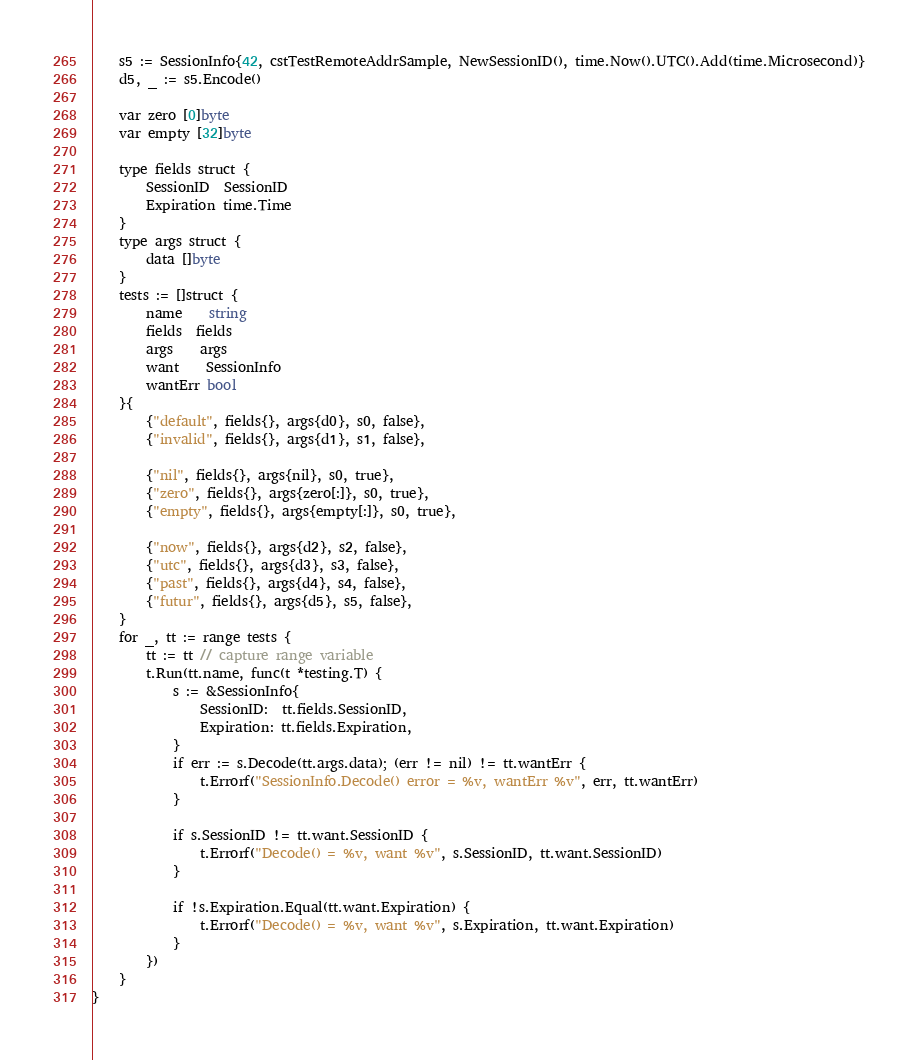<code> <loc_0><loc_0><loc_500><loc_500><_Go_>
	s5 := SessionInfo{42, cstTestRemoteAddrSample, NewSessionID(), time.Now().UTC().Add(time.Microsecond)}
	d5, _ := s5.Encode()

	var zero [0]byte
	var empty [32]byte

	type fields struct {
		SessionID  SessionID
		Expiration time.Time
	}
	type args struct {
		data []byte
	}
	tests := []struct {
		name    string
		fields  fields
		args    args
		want    SessionInfo
		wantErr bool
	}{
		{"default", fields{}, args{d0}, s0, false},
		{"invalid", fields{}, args{d1}, s1, false},

		{"nil", fields{}, args{nil}, s0, true},
		{"zero", fields{}, args{zero[:]}, s0, true},
		{"empty", fields{}, args{empty[:]}, s0, true},

		{"now", fields{}, args{d2}, s2, false},
		{"utc", fields{}, args{d3}, s3, false},
		{"past", fields{}, args{d4}, s4, false},
		{"futur", fields{}, args{d5}, s5, false},
	}
	for _, tt := range tests {
		tt := tt // capture range variable
		t.Run(tt.name, func(t *testing.T) {
			s := &SessionInfo{
				SessionID:  tt.fields.SessionID,
				Expiration: tt.fields.Expiration,
			}
			if err := s.Decode(tt.args.data); (err != nil) != tt.wantErr {
				t.Errorf("SessionInfo.Decode() error = %v, wantErr %v", err, tt.wantErr)
			}

			if s.SessionID != tt.want.SessionID {
				t.Errorf("Decode() = %v, want %v", s.SessionID, tt.want.SessionID)
			}

			if !s.Expiration.Equal(tt.want.Expiration) {
				t.Errorf("Decode() = %v, want %v", s.Expiration, tt.want.Expiration)
			}
		})
	}
}
</code> 